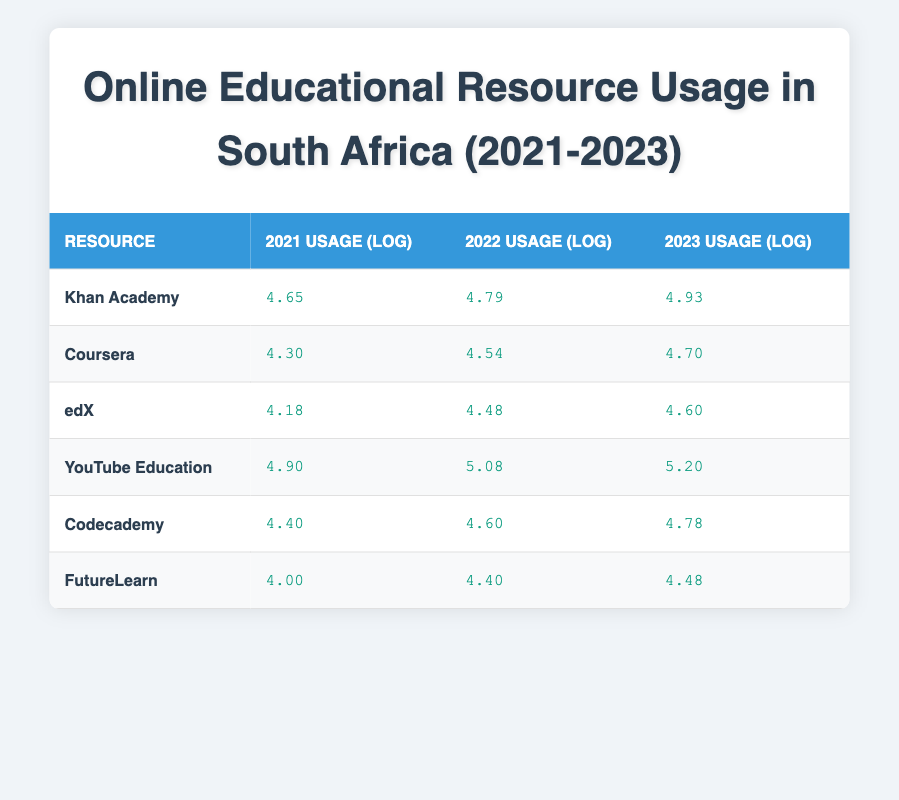What was the usage of YouTube Education in 2023? According to the table, the usage of YouTube Education in 2023 is listed as 5.20 in logarithmic value.
Answer: 5.20 Which resource had the highest usage increase from 2021 to 2023? To determine the resource with the highest increase, we calculate the difference between the 2021 and 2023 usage for each resource. YouTube Education had an increase from 4.90 to 5.20, Khan Academy from 4.65 to 4.93, and so on. YouTube Education had the largest increase of 0.30.
Answer: YouTube Education Is it true that Coursera had higher usage than edX in all three years? Checking the table, Coursera’s usage (log values) are 4.30 (2021), 4.54 (2022), and 4.70 (2023), which are all higher than edX’s values of 4.18 (2021), 4.48 (2022), and 4.60 (2023). Therefore, it is true.
Answer: Yes What is the average usage value of FutureLearn over the three years? The usage values for FutureLearn are 4.00 (2021), 4.40 (2022), and 4.48 (2023). Adding these values together gives 4.00 + 4.40 + 4.48 = 12.88. Dividing by 3 gives an average of 12.88/3 = 4.293, which rounds to 4.29.
Answer: 4.29 Which resource showed the least growth in usage from 2021 to 2022? To find the least growth, compare the differences in usage between 2021 and 2022 for each resource. FutureLearn had an increase of 0.40 (4.00 to 4.40), which is the smallest compared to others.
Answer: FutureLearn What is the total sum of usage in logarithmic values for Khan Academy and Codecademy in 2022? The log values for Khan Academy and Codecademy in 2022 are 4.79 and 4.60, respectively. Adding these values gives 4.79 + 4.60 = 9.39.
Answer: 9.39 